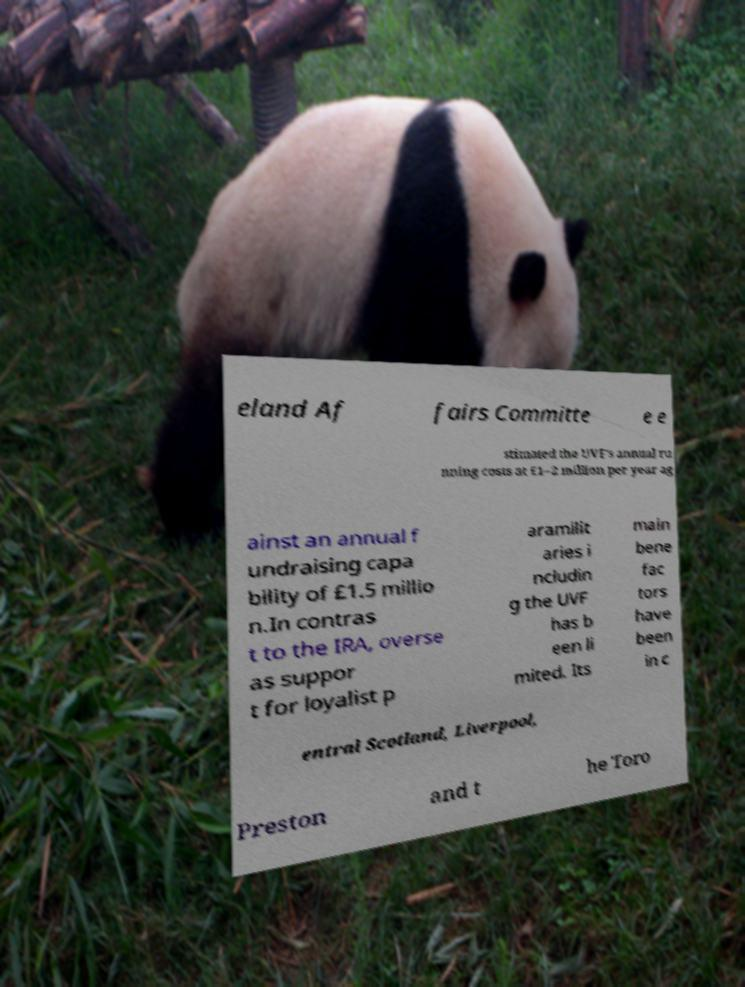Can you accurately transcribe the text from the provided image for me? eland Af fairs Committe e e stimated the UVF's annual ru nning costs at £1–2 million per year ag ainst an annual f undraising capa bility of £1.5 millio n.In contras t to the IRA, overse as suppor t for loyalist p aramilit aries i ncludin g the UVF has b een li mited. Its main bene fac tors have been in c entral Scotland, Liverpool, Preston and t he Toro 